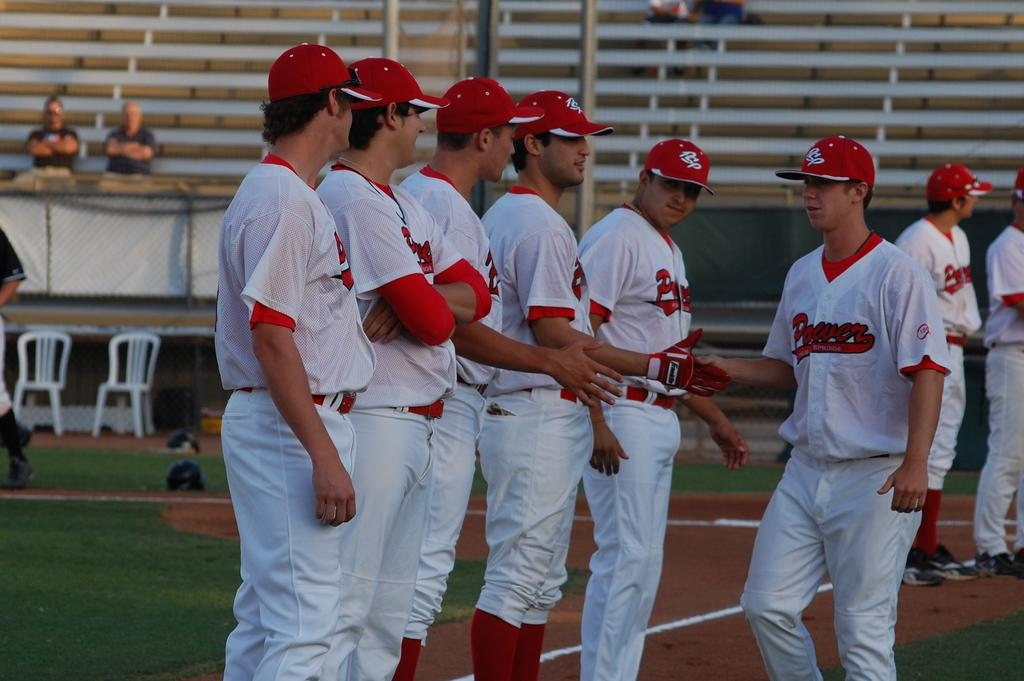<image>
Offer a succinct explanation of the picture presented. A number of players from the Power baseball team on the field. 